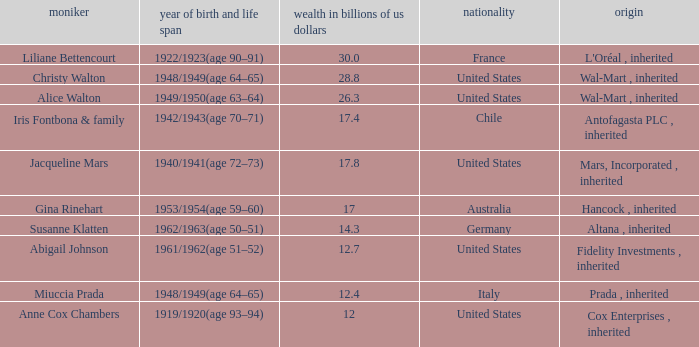What's the source of wealth of the person worth $17 billion? Hancock , inherited. 